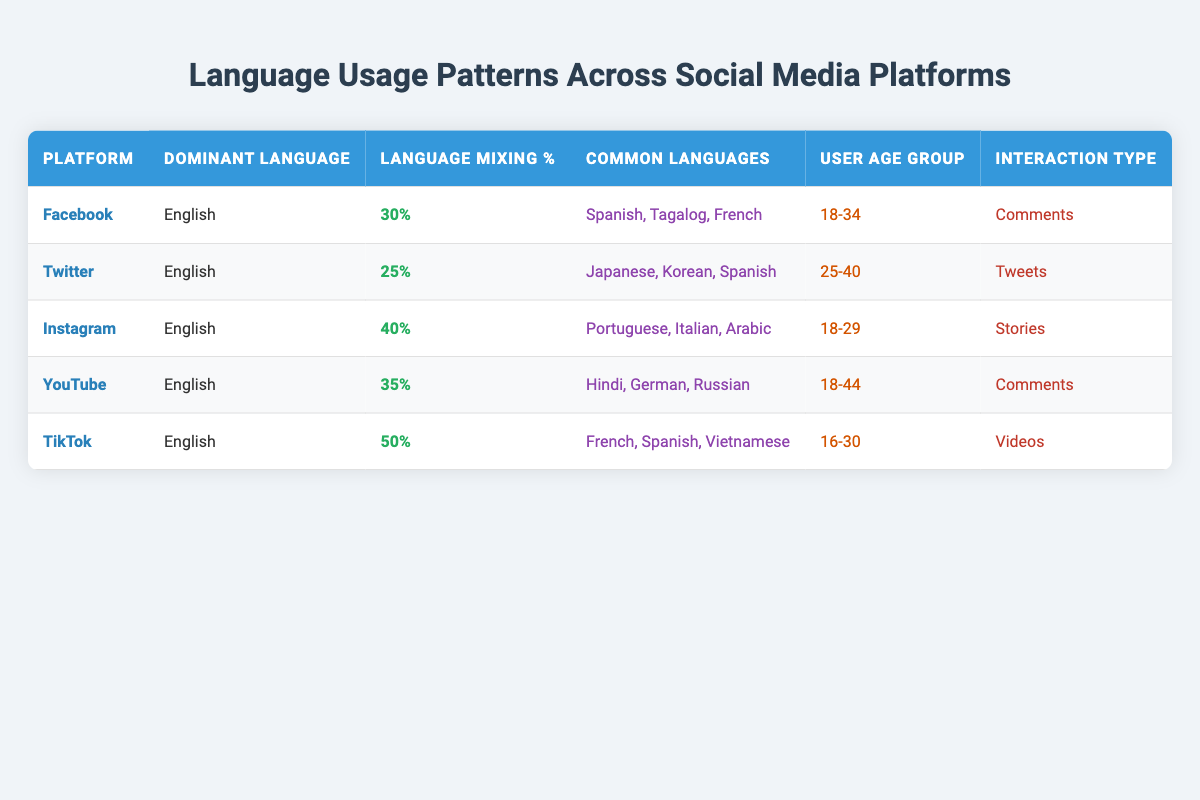What is the dominant language used on TikTok? The table shows that the dominant language for TikTok is "English."
Answer: English Which social media platform has the highest language mixing percentage? According to the table, TikTok has the highest language mixing percentage at 50%.
Answer: TikTok Are comments a common interaction type on Facebook? Yes, the table indicates that "Comments" are the interaction type for Facebook.
Answer: Yes How many common languages are listed for Instagram? The table states that Instagram has three common languages: "Portuguese, Italian, Arabic." Therefore, the total is 3.
Answer: 3 What is the average language mixing percentage across all platforms listed? The language mixing percentages are 30%, 25%, 40%, 35%, and 50%. Summing these gives 30 + 25 + 40 + 35 + 50 = 180. Dividing by 5 (the number of platforms) results in an average of 36.
Answer: 36 Which user age group uses social media primarily for videos? The table specifies that the user age group for TikTok (which uses videos) is "16-30."
Answer: 16-30 Is Spanish a common language for Twitter? Yes, the table lists "Spanish" among the common languages for Twitter.
Answer: Yes What are the common languages used on Facebook? According to the table, the common languages for Facebook are "Spanish, Tagalog, French."
Answer: Spanish, Tagalog, French Which platform has the oldest user age group based on the data provided? By comparing the user age groups, YouTube (18-44) has the oldest range, thus indicating it caters to older users.
Answer: YouTube 